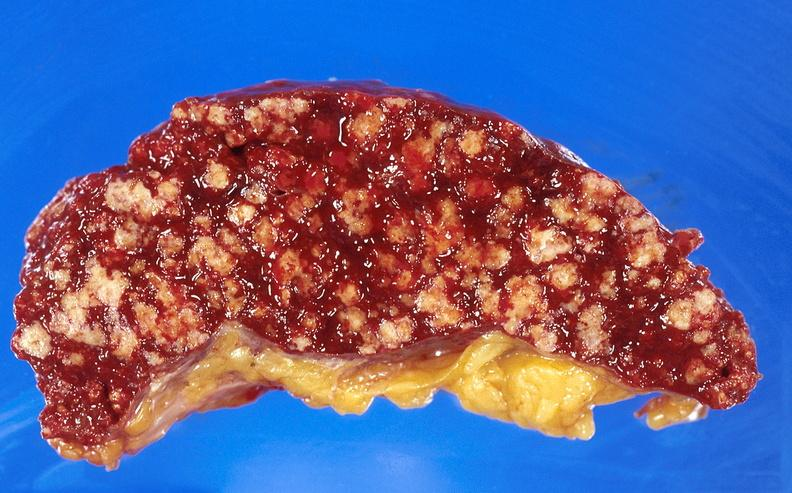what is present?
Answer the question using a single word or phrase. Hematologic 